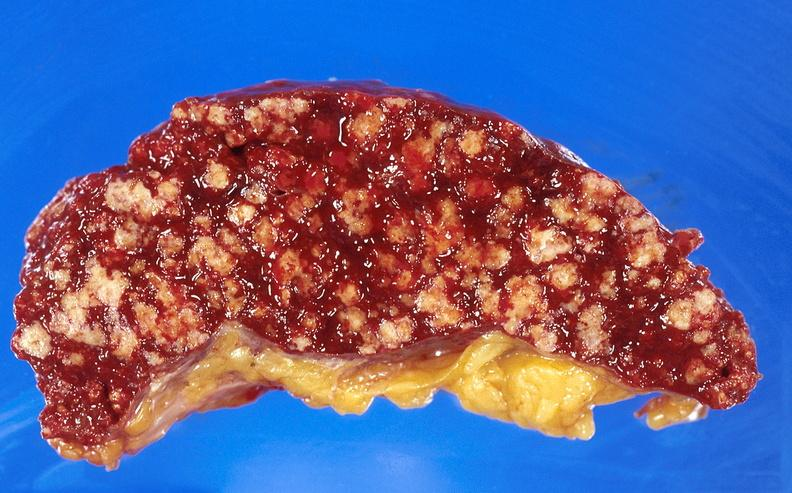what is present?
Answer the question using a single word or phrase. Hematologic 